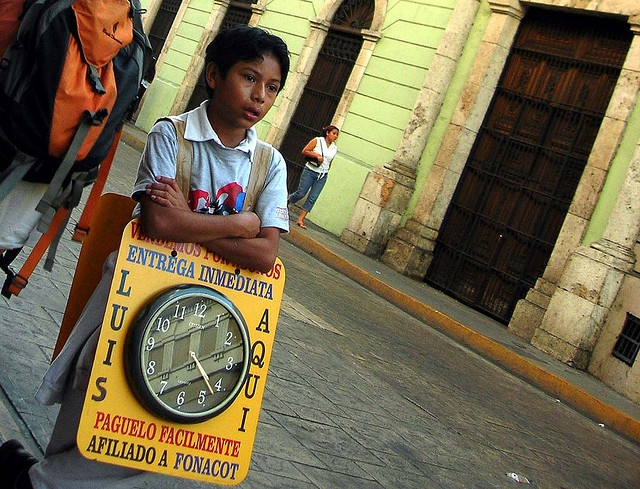Describe the objects in this image and their specific colors. I can see people in maroon, black, and gray tones, backpack in maroon, black, and brown tones, clock in maroon, gray, black, and darkgray tones, backpack in maroon, darkgray, gray, and lightgray tones, and people in maroon, ivory, black, blue, and gray tones in this image. 